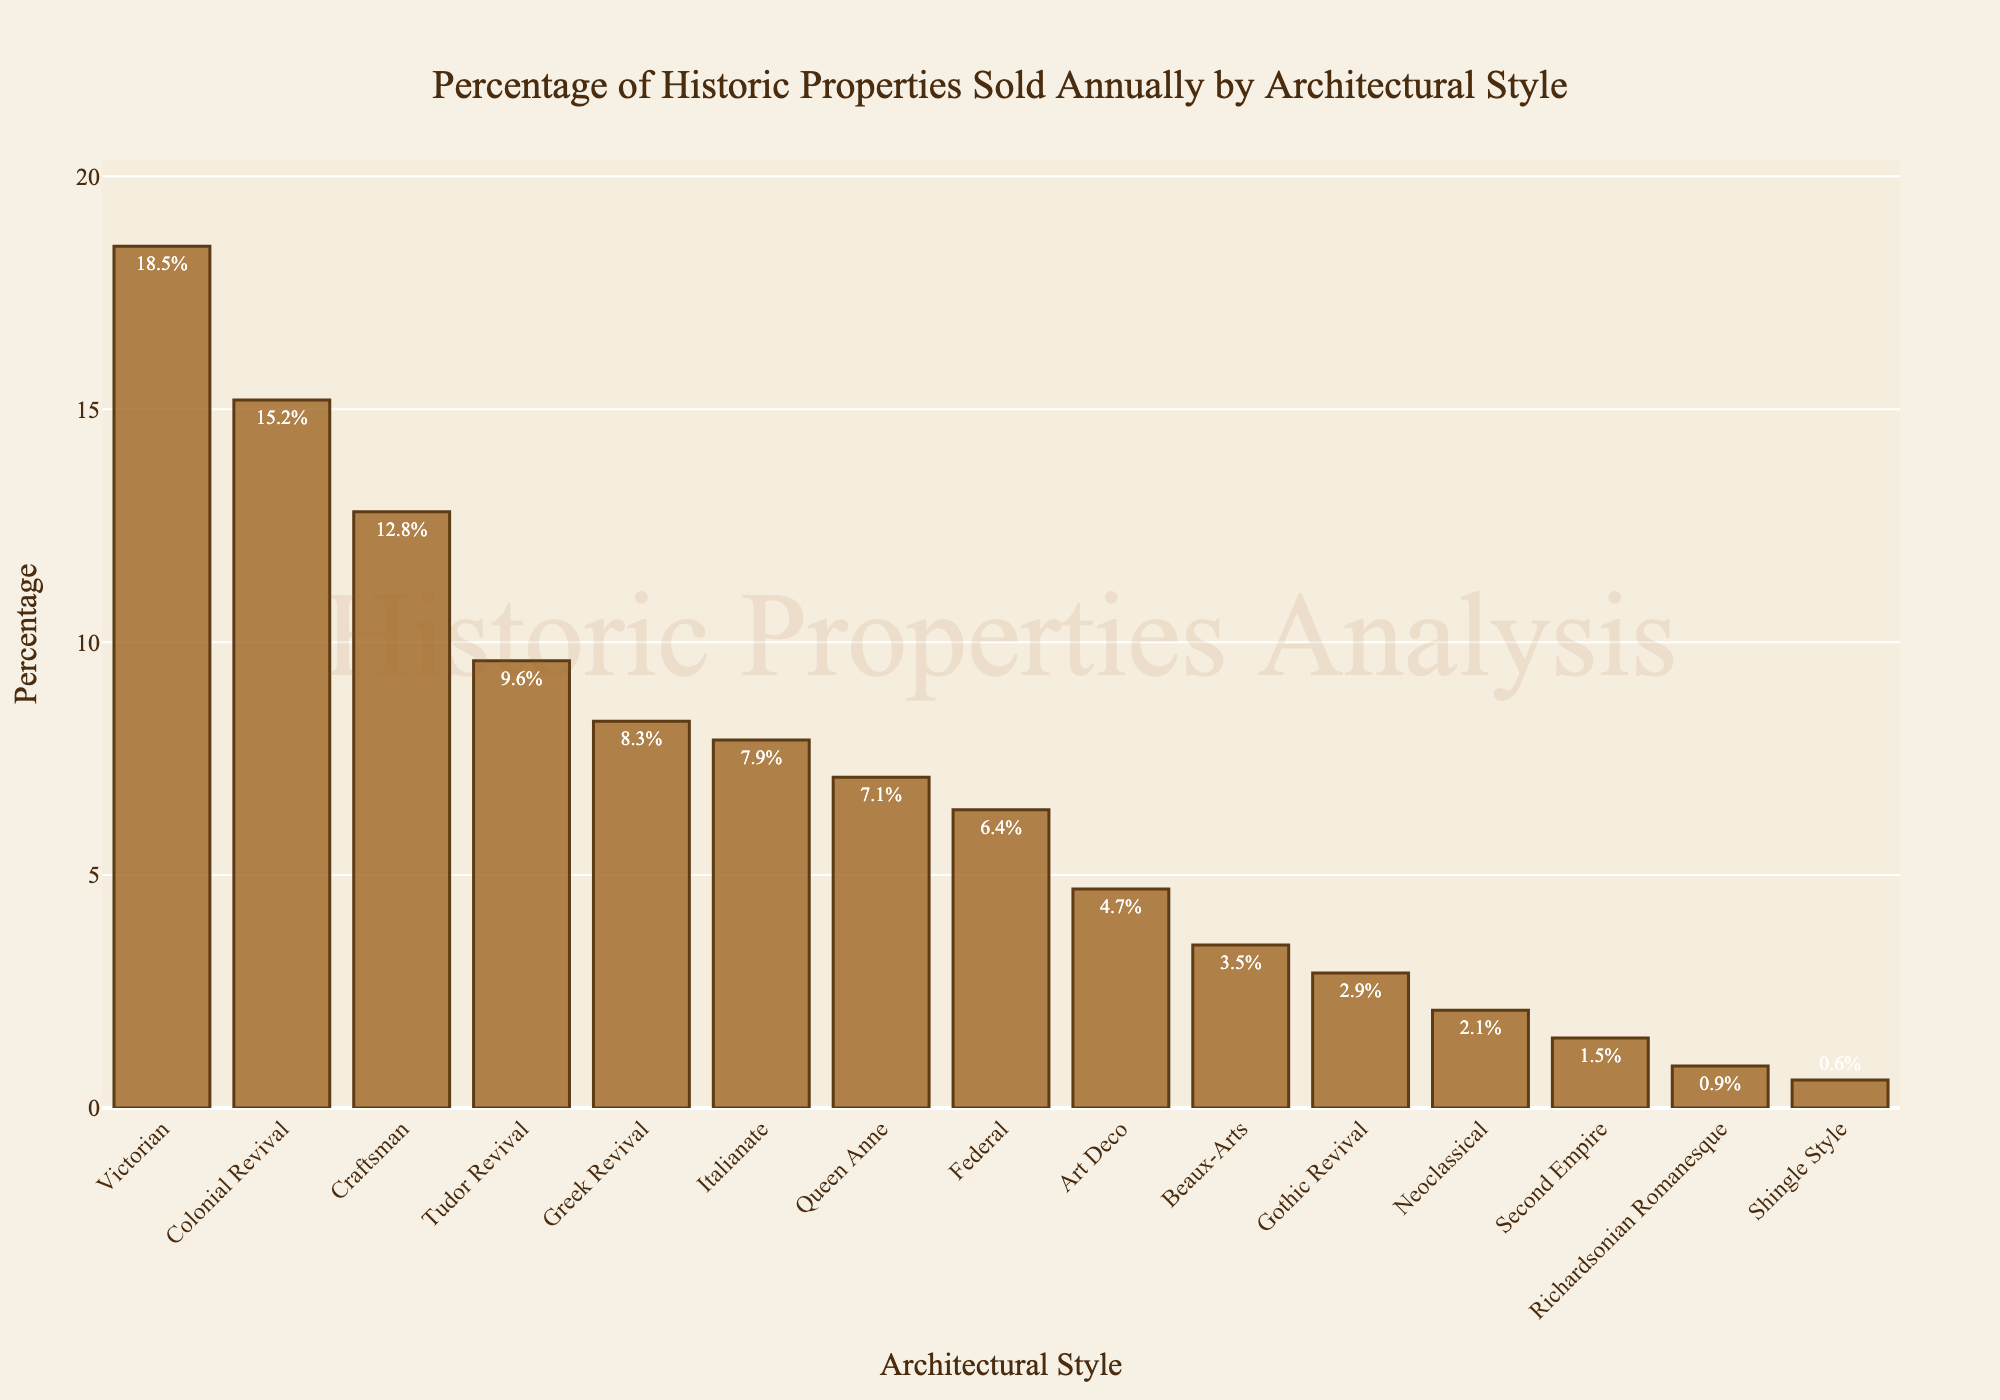Which architectural style has the highest percentage of properties sold? To determine the architectural style with the highest percentage of properties sold, find the tallest bar in the chart. The bar labeled 'Victorian' is the tallest with a percentage of 18.5%.
Answer: Victorian How much more is the percentage of Victorian properties sold compared to Colonial Revival properties? Identify the percentage values for Victorian (18.5%) and Colonial Revival (15.2%). Then, calculate the difference: 18.5% - 15.2% = 3.3%.
Answer: 3.3% What is the combined percentage of properties sold for Craftsman, Tudor Revival, and Greek Revival styles? Sum the percentages for Craftsman (12.8%), Tudor Revival (9.6%), and Greek Revival (8.3%): 12.8% + 9.6% + 8.3% = 30.7%.
Answer: 30.7% Which architectural style has the smallest percentage of properties sold? Look for the shortest bar in the chart. The 'Shingle Style' bar is the shortest with a percentage of 0.6%.
Answer: Shingle Style How does the percentage of properties sold for Italianate compare to Queen Anne? Identify the percentages for Italianate (7.9%) and Queen Anne (7.1%). Italianate's percentage is higher by 0.8%.
Answer: Italianate is 0.8% higher What is the average percentage of properties sold among the top three architectural styles? The top three styles are Victorian (18.5%), Colonial Revival (15.2%), and Craftsman (12.8%). Calculate the average: (18.5% + 15.2% + 12.8%) / 3 = 15.5%.
Answer: 15.5% Between Beaux-Arts and Gothic Revival, which style has a larger percentage of properties sold, and by how much? Identify the percentages for Beaux-Arts (3.5%) and Gothic Revival (2.9%). Beaux-Arts has a larger percentage. Calculate the difference: 3.5% - 2.9% = 0.6%.
Answer: Beaux-Arts by 0.6% What percentage of properties are sold for the styles under 5%? Identify the styles under 5%: Art Deco (4.7%), Beaux-Arts (3.5%), Gothic Revival (2.9%), Neoclassical (2.1%), Second Empire (1.5%), Richardsonian Romanesque (0.9%), Shingle Style (0.6%). Sum these percentages: 4.7% + 3.5% + 2.9% + 2.1% + 1.5% + 0.9% + 0.6% = 16.2%.
Answer: 16.2% 